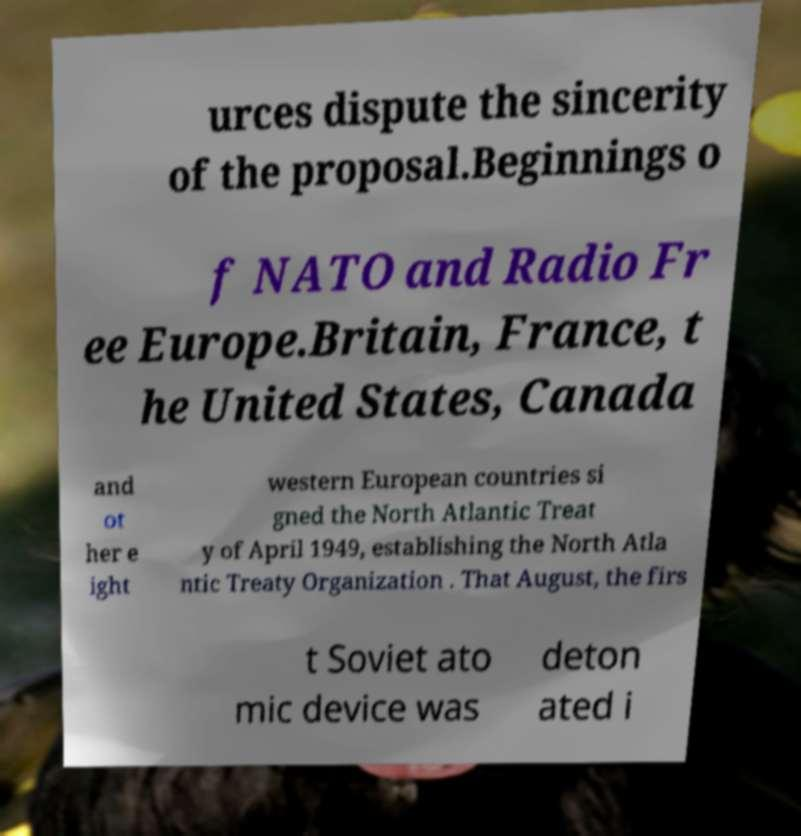There's text embedded in this image that I need extracted. Can you transcribe it verbatim? urces dispute the sincerity of the proposal.Beginnings o f NATO and Radio Fr ee Europe.Britain, France, t he United States, Canada and ot her e ight western European countries si gned the North Atlantic Treat y of April 1949, establishing the North Atla ntic Treaty Organization . That August, the firs t Soviet ato mic device was deton ated i 